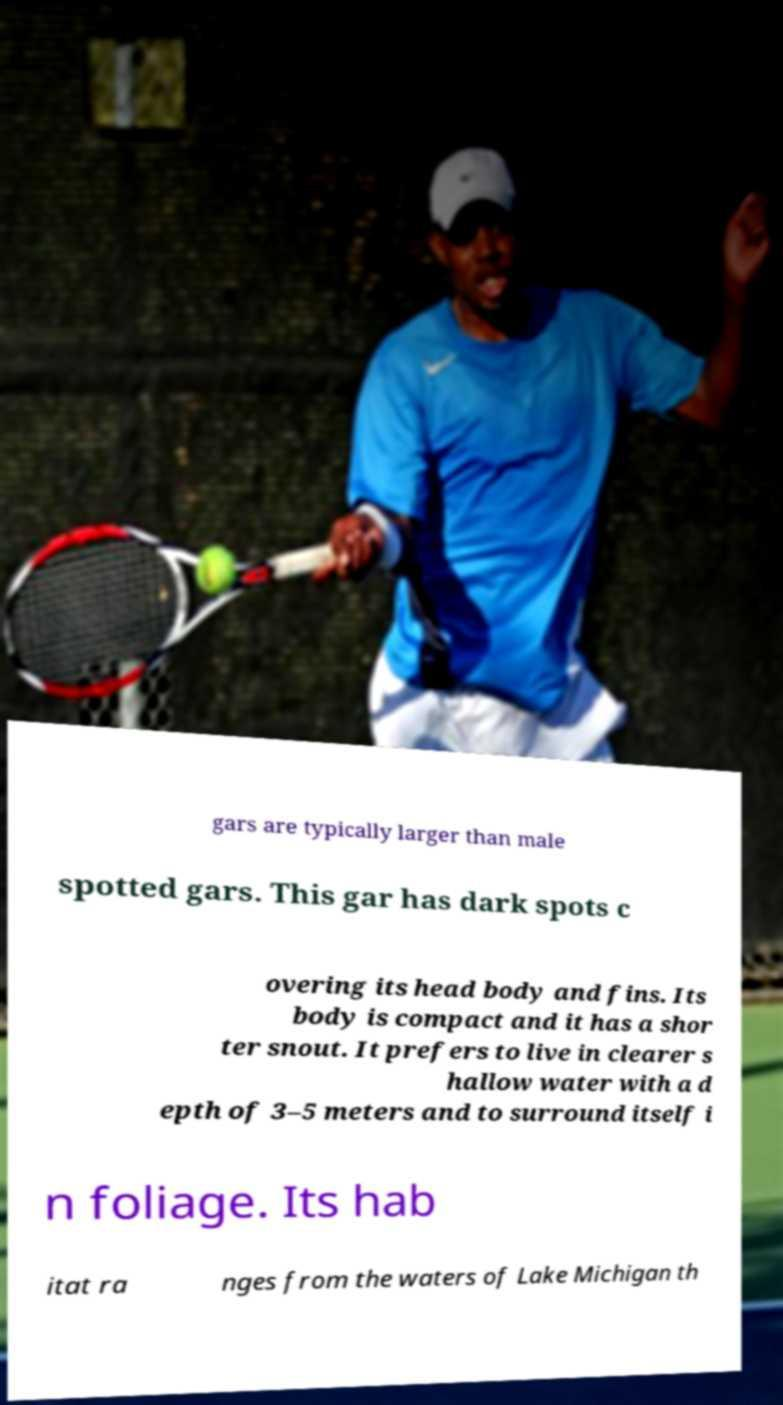Could you extract and type out the text from this image? gars are typically larger than male spotted gars. This gar has dark spots c overing its head body and fins. Its body is compact and it has a shor ter snout. It prefers to live in clearer s hallow water with a d epth of 3–5 meters and to surround itself i n foliage. Its hab itat ra nges from the waters of Lake Michigan th 